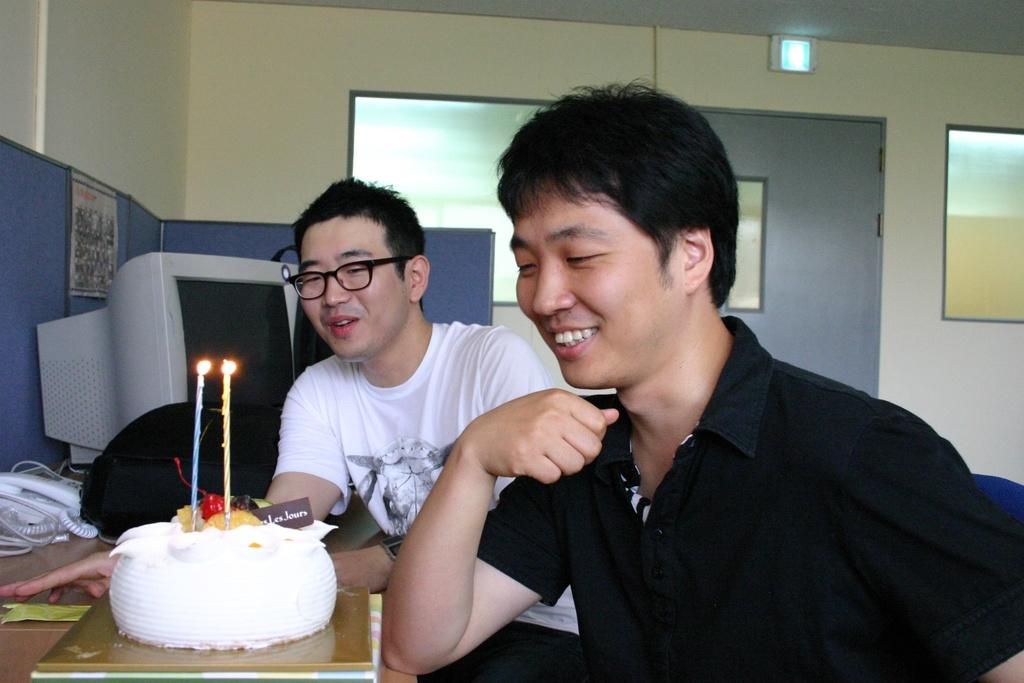How many people are in the image? There are two persons in the image. What is the main piece of furniture in the image? There is a table in the image. What is on top of the table? A cake, a telephone, a bag, and a PC are on the table. What can be seen in the background of the image? There is a wall and windows in the background of the image. Where is the image taken? The image is taken in a room. What type of smile can be seen on the harbor in the image? There is no harbor present in the image, and therefore no smile can be observed. How does the person in the image control the PC? The image does not show the person interacting with the PC, so it cannot be determined how they control it. 